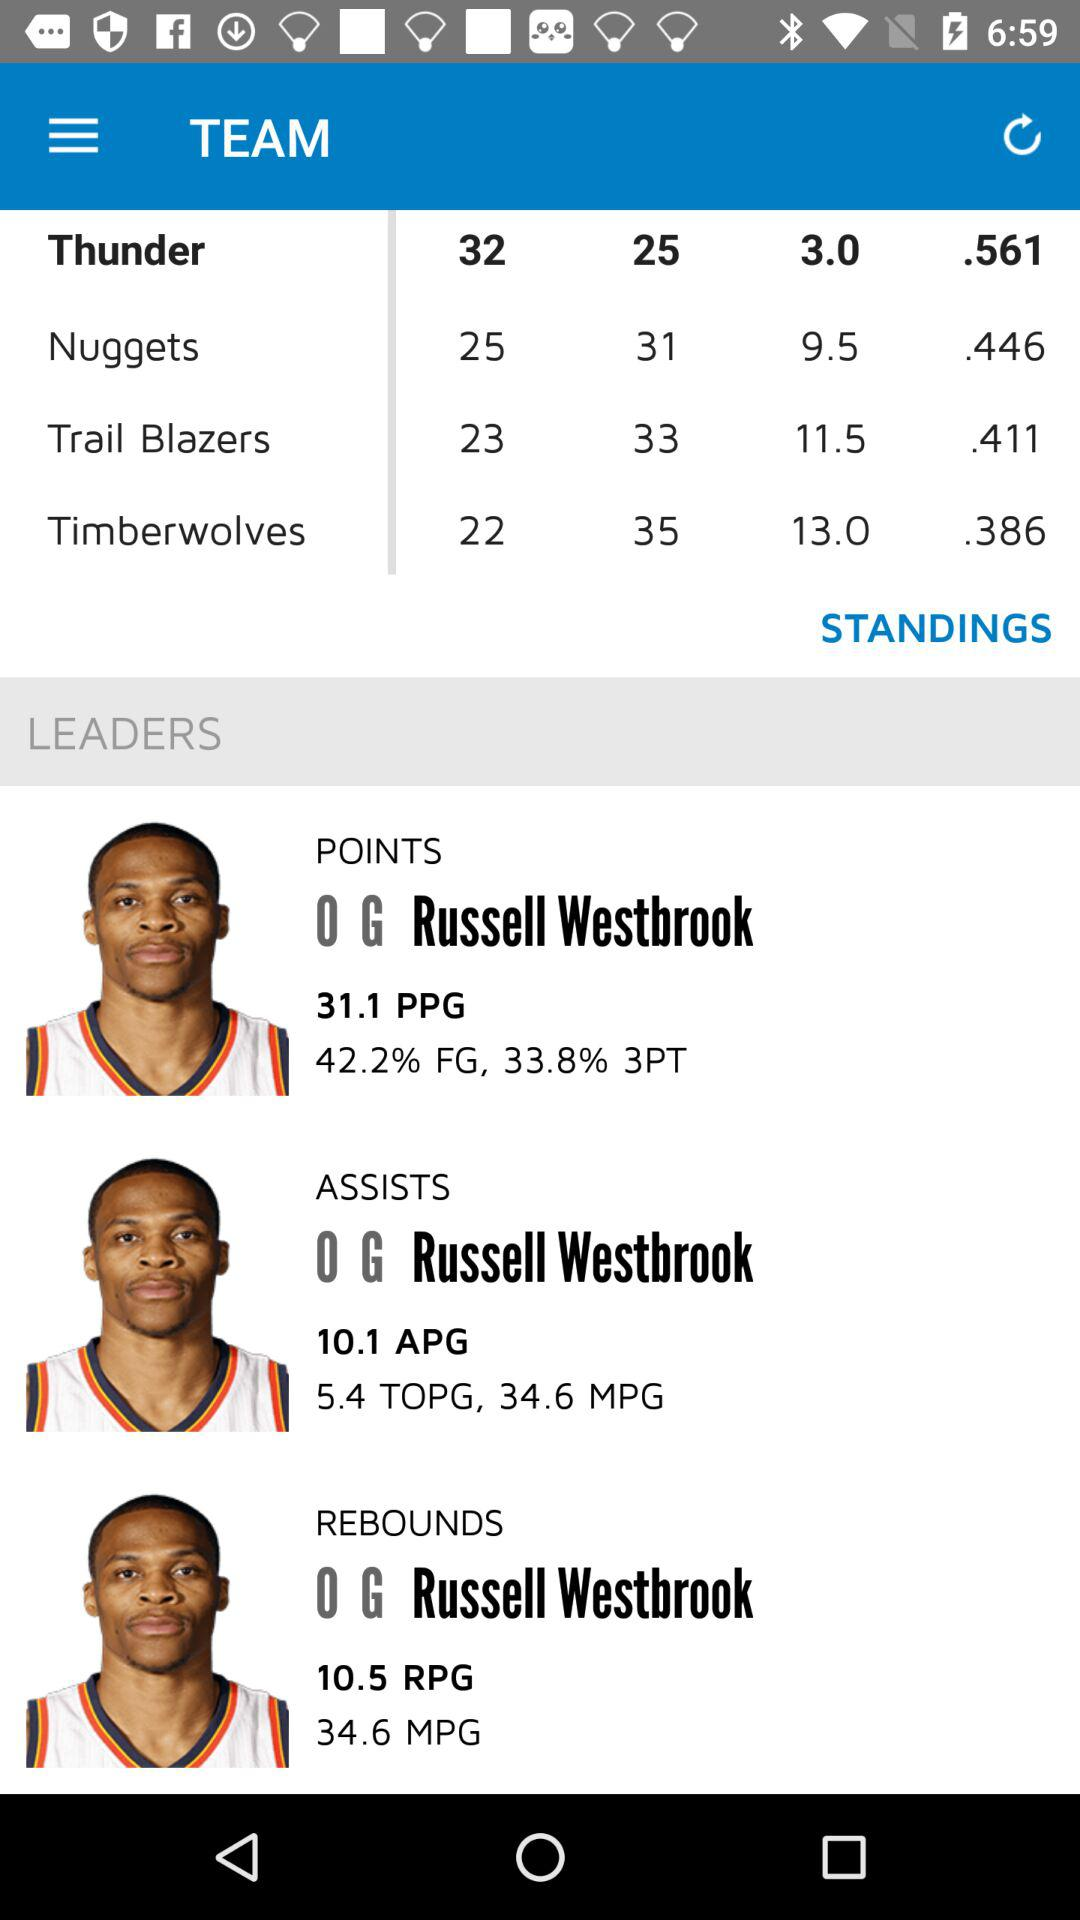How many more points did Russell Westbrook score than assists?
Answer the question using a single word or phrase. 21.0 